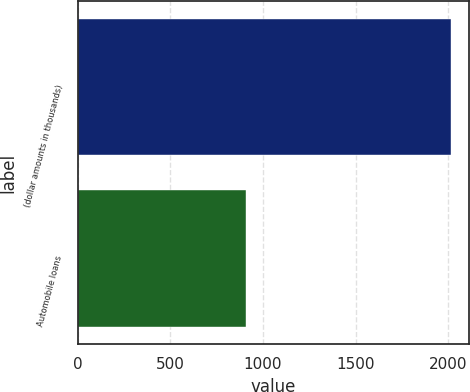Convert chart to OTSL. <chart><loc_0><loc_0><loc_500><loc_500><bar_chart><fcel>(dollar amounts in thousands)<fcel>Automobile loans<nl><fcel>2014<fcel>911<nl></chart> 